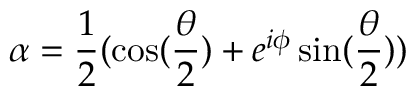Convert formula to latex. <formula><loc_0><loc_0><loc_500><loc_500>\alpha = \frac { 1 } { 2 } ( \cos ( \frac { \theta } { 2 } ) + e ^ { i \phi } \sin ( \frac { \theta } { 2 } ) )</formula> 